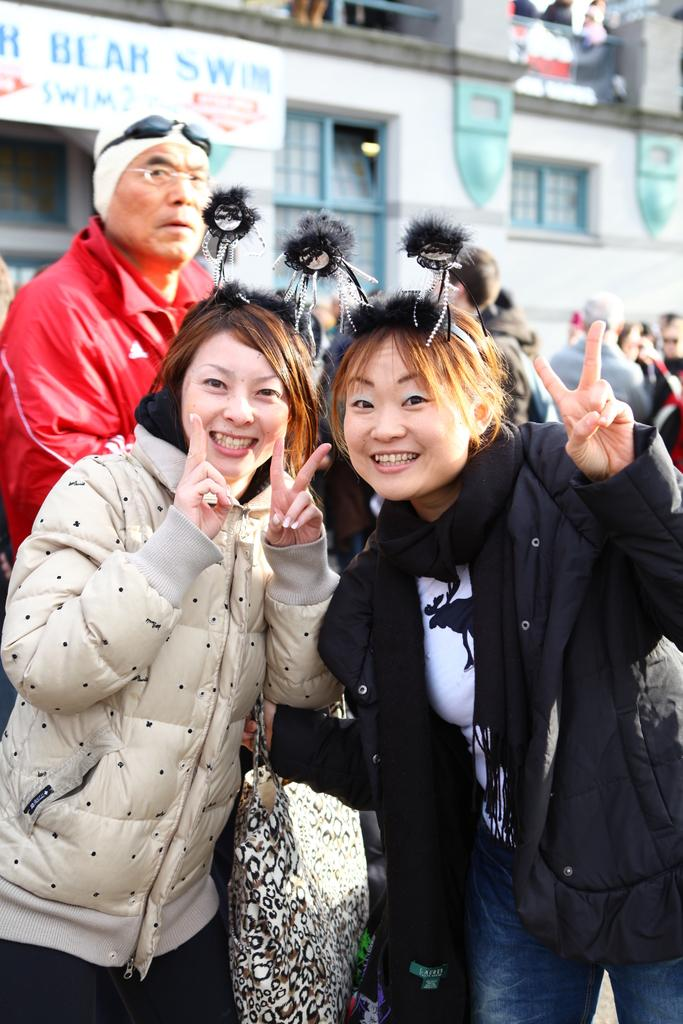Who are the main subjects in the image? There are two girls in the middle of the image. What are the girls doing in the image? The girls are showing their fingers. Can you describe the people in the background of the image? There are other people in the background of the image, and they are standing on the floor. What can be seen in the background of the image besides the people? There is a building in the background of the image. What type of structure can be seen in the image? There is no specific structure mentioned in the provided facts. The only structure mentioned is a building in the background, but it is not described as a specific type of structure. 